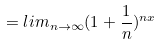Convert formula to latex. <formula><loc_0><loc_0><loc_500><loc_500>= l i m _ { n \rightarrow \infty } ( 1 + \frac { 1 } { n } ) ^ { n x }</formula> 